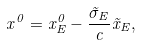<formula> <loc_0><loc_0><loc_500><loc_500>x ^ { 0 } = x ^ { 0 } _ { E } - \frac { \vec { \sigma } _ { E } } { c } \vec { x } _ { E } ,</formula> 